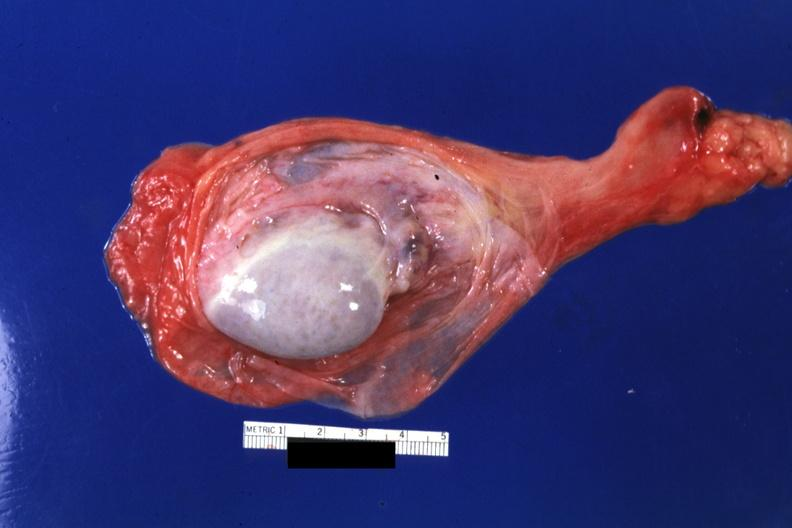s hydrocele present?
Answer the question using a single word or phrase. Yes 